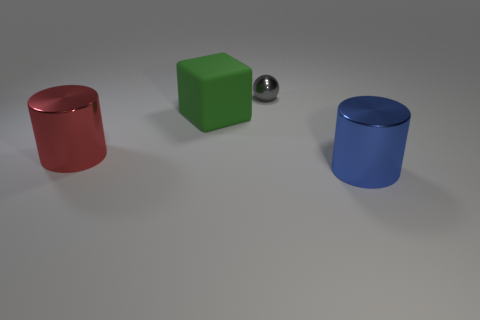Are there any other things that are the same material as the cube?
Make the answer very short. No. What number of big objects are behind the object that is to the right of the metal object behind the green matte cube?
Offer a very short reply. 2. There is a red object; what number of large shiny cylinders are right of it?
Give a very brief answer. 1. What number of red cylinders have the same material as the tiny sphere?
Keep it short and to the point. 1. There is a sphere that is made of the same material as the large blue cylinder; what color is it?
Make the answer very short. Gray. There is a cylinder behind the shiny cylinder that is in front of the big shiny object to the left of the big blue thing; what is it made of?
Offer a very short reply. Metal. There is a thing to the right of the shiny sphere; does it have the same size as the big green rubber thing?
Ensure brevity in your answer.  Yes. How many small things are either green cubes or blue shiny balls?
Keep it short and to the point. 0. Is there a big cube that has the same color as the big rubber object?
Your answer should be very brief. No. What shape is the green object that is the same size as the blue cylinder?
Ensure brevity in your answer.  Cube. 